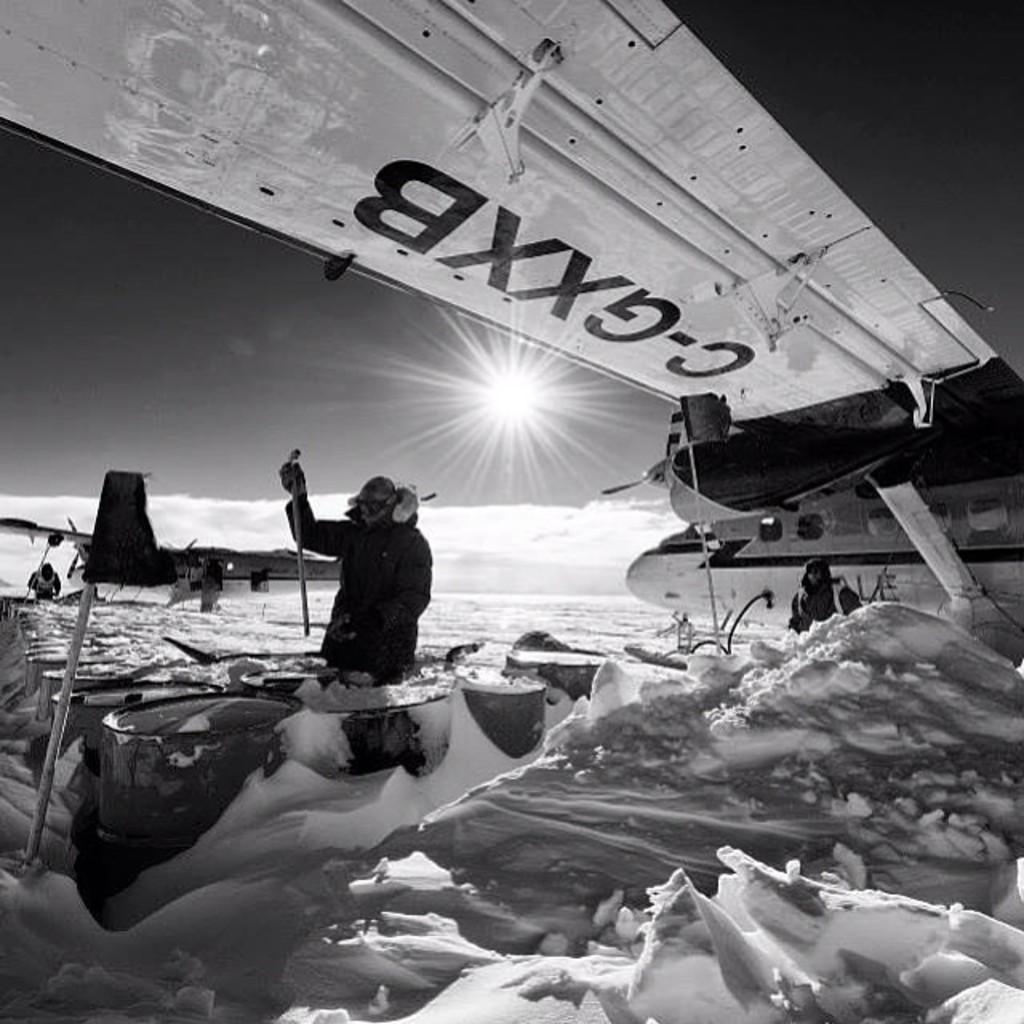How would you summarize this image in a sentence or two? In this image there is an airplane in the snow. In the middle there is a man who is standing near the drums. At the top there is light. At the bottom there is snow. It is the black and white image. Behind the man there is another airplane on the snow. 